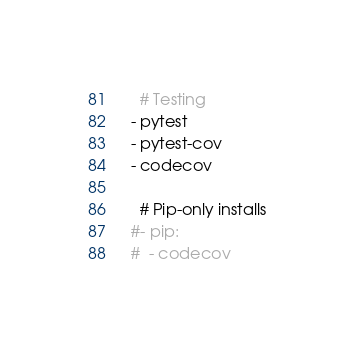Convert code to text. <code><loc_0><loc_0><loc_500><loc_500><_YAML_>    # Testing
  - pytest
  - pytest-cov
  - codecov

    # Pip-only installs
  #- pip:
  #  - codecov

</code> 